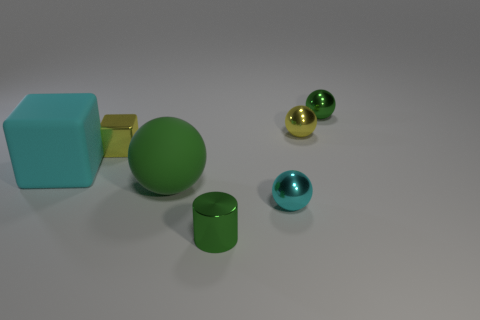Is there a tiny purple cylinder that has the same material as the big cyan thing?
Ensure brevity in your answer.  No. How many objects are either large green rubber things or large green metal spheres?
Your answer should be compact. 1. Does the tiny cyan object have the same material as the green sphere that is on the left side of the green cylinder?
Keep it short and to the point. No. There is a yellow object that is on the right side of the tiny metal cylinder; what size is it?
Your response must be concise. Small. Are there fewer small green cubes than matte things?
Make the answer very short. Yes. Is there a big ball that has the same color as the small metal cylinder?
Give a very brief answer. Yes. What shape is the small shiny thing that is both behind the small cylinder and in front of the yellow shiny cube?
Your response must be concise. Sphere. What is the shape of the small green shiny object in front of the yellow object that is right of the tiny shiny cube?
Make the answer very short. Cylinder. Do the cyan shiny thing and the cyan matte object have the same shape?
Offer a very short reply. No. There is a ball that is the same color as the tiny metallic cube; what is its material?
Your answer should be very brief. Metal. 